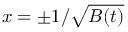Convert formula to latex. <formula><loc_0><loc_0><loc_500><loc_500>x = \pm { 1 } / { \sqrt { B ( t ) } }</formula> 